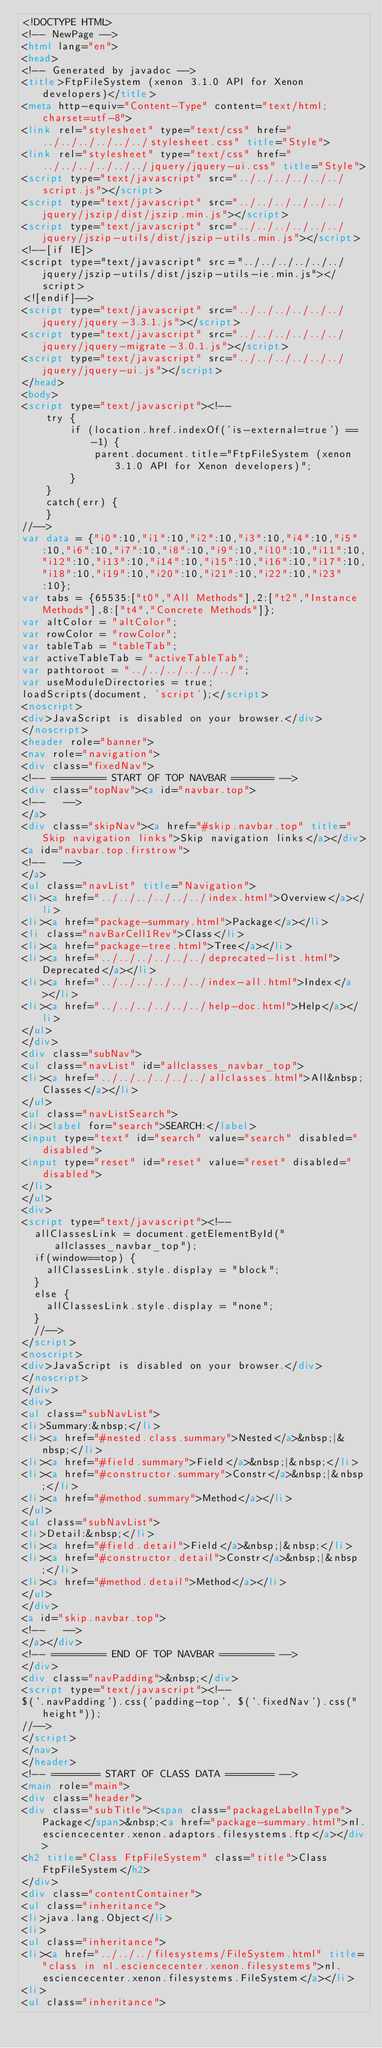<code> <loc_0><loc_0><loc_500><loc_500><_HTML_><!DOCTYPE HTML>
<!-- NewPage -->
<html lang="en">
<head>
<!-- Generated by javadoc -->
<title>FtpFileSystem (xenon 3.1.0 API for Xenon developers)</title>
<meta http-equiv="Content-Type" content="text/html; charset=utf-8">
<link rel="stylesheet" type="text/css" href="../../../../../../stylesheet.css" title="Style">
<link rel="stylesheet" type="text/css" href="../../../../../../jquery/jquery-ui.css" title="Style">
<script type="text/javascript" src="../../../../../../script.js"></script>
<script type="text/javascript" src="../../../../../../jquery/jszip/dist/jszip.min.js"></script>
<script type="text/javascript" src="../../../../../../jquery/jszip-utils/dist/jszip-utils.min.js"></script>
<!--[if IE]>
<script type="text/javascript" src="../../../../../../jquery/jszip-utils/dist/jszip-utils-ie.min.js"></script>
<![endif]-->
<script type="text/javascript" src="../../../../../../jquery/jquery-3.3.1.js"></script>
<script type="text/javascript" src="../../../../../../jquery/jquery-migrate-3.0.1.js"></script>
<script type="text/javascript" src="../../../../../../jquery/jquery-ui.js"></script>
</head>
<body>
<script type="text/javascript"><!--
    try {
        if (location.href.indexOf('is-external=true') == -1) {
            parent.document.title="FtpFileSystem (xenon 3.1.0 API for Xenon developers)";
        }
    }
    catch(err) {
    }
//-->
var data = {"i0":10,"i1":10,"i2":10,"i3":10,"i4":10,"i5":10,"i6":10,"i7":10,"i8":10,"i9":10,"i10":10,"i11":10,"i12":10,"i13":10,"i14":10,"i15":10,"i16":10,"i17":10,"i18":10,"i19":10,"i20":10,"i21":10,"i22":10,"i23":10};
var tabs = {65535:["t0","All Methods"],2:["t2","Instance Methods"],8:["t4","Concrete Methods"]};
var altColor = "altColor";
var rowColor = "rowColor";
var tableTab = "tableTab";
var activeTableTab = "activeTableTab";
var pathtoroot = "../../../../../../";
var useModuleDirectories = true;
loadScripts(document, 'script');</script>
<noscript>
<div>JavaScript is disabled on your browser.</div>
</noscript>
<header role="banner">
<nav role="navigation">
<div class="fixedNav">
<!-- ========= START OF TOP NAVBAR ======= -->
<div class="topNav"><a id="navbar.top">
<!--   -->
</a>
<div class="skipNav"><a href="#skip.navbar.top" title="Skip navigation links">Skip navigation links</a></div>
<a id="navbar.top.firstrow">
<!--   -->
</a>
<ul class="navList" title="Navigation">
<li><a href="../../../../../../index.html">Overview</a></li>
<li><a href="package-summary.html">Package</a></li>
<li class="navBarCell1Rev">Class</li>
<li><a href="package-tree.html">Tree</a></li>
<li><a href="../../../../../../deprecated-list.html">Deprecated</a></li>
<li><a href="../../../../../../index-all.html">Index</a></li>
<li><a href="../../../../../../help-doc.html">Help</a></li>
</ul>
</div>
<div class="subNav">
<ul class="navList" id="allclasses_navbar_top">
<li><a href="../../../../../../allclasses.html">All&nbsp;Classes</a></li>
</ul>
<ul class="navListSearch">
<li><label for="search">SEARCH:</label>
<input type="text" id="search" value="search" disabled="disabled">
<input type="reset" id="reset" value="reset" disabled="disabled">
</li>
</ul>
<div>
<script type="text/javascript"><!--
  allClassesLink = document.getElementById("allclasses_navbar_top");
  if(window==top) {
    allClassesLink.style.display = "block";
  }
  else {
    allClassesLink.style.display = "none";
  }
  //-->
</script>
<noscript>
<div>JavaScript is disabled on your browser.</div>
</noscript>
</div>
<div>
<ul class="subNavList">
<li>Summary:&nbsp;</li>
<li><a href="#nested.class.summary">Nested</a>&nbsp;|&nbsp;</li>
<li><a href="#field.summary">Field</a>&nbsp;|&nbsp;</li>
<li><a href="#constructor.summary">Constr</a>&nbsp;|&nbsp;</li>
<li><a href="#method.summary">Method</a></li>
</ul>
<ul class="subNavList">
<li>Detail:&nbsp;</li>
<li><a href="#field.detail">Field</a>&nbsp;|&nbsp;</li>
<li><a href="#constructor.detail">Constr</a>&nbsp;|&nbsp;</li>
<li><a href="#method.detail">Method</a></li>
</ul>
</div>
<a id="skip.navbar.top">
<!--   -->
</a></div>
<!-- ========= END OF TOP NAVBAR ========= -->
</div>
<div class="navPadding">&nbsp;</div>
<script type="text/javascript"><!--
$('.navPadding').css('padding-top', $('.fixedNav').css("height"));
//-->
</script>
</nav>
</header>
<!-- ======== START OF CLASS DATA ======== -->
<main role="main">
<div class="header">
<div class="subTitle"><span class="packageLabelInType">Package</span>&nbsp;<a href="package-summary.html">nl.esciencecenter.xenon.adaptors.filesystems.ftp</a></div>
<h2 title="Class FtpFileSystem" class="title">Class FtpFileSystem</h2>
</div>
<div class="contentContainer">
<ul class="inheritance">
<li>java.lang.Object</li>
<li>
<ul class="inheritance">
<li><a href="../../../filesystems/FileSystem.html" title="class in nl.esciencecenter.xenon.filesystems">nl.esciencecenter.xenon.filesystems.FileSystem</a></li>
<li>
<ul class="inheritance"></code> 